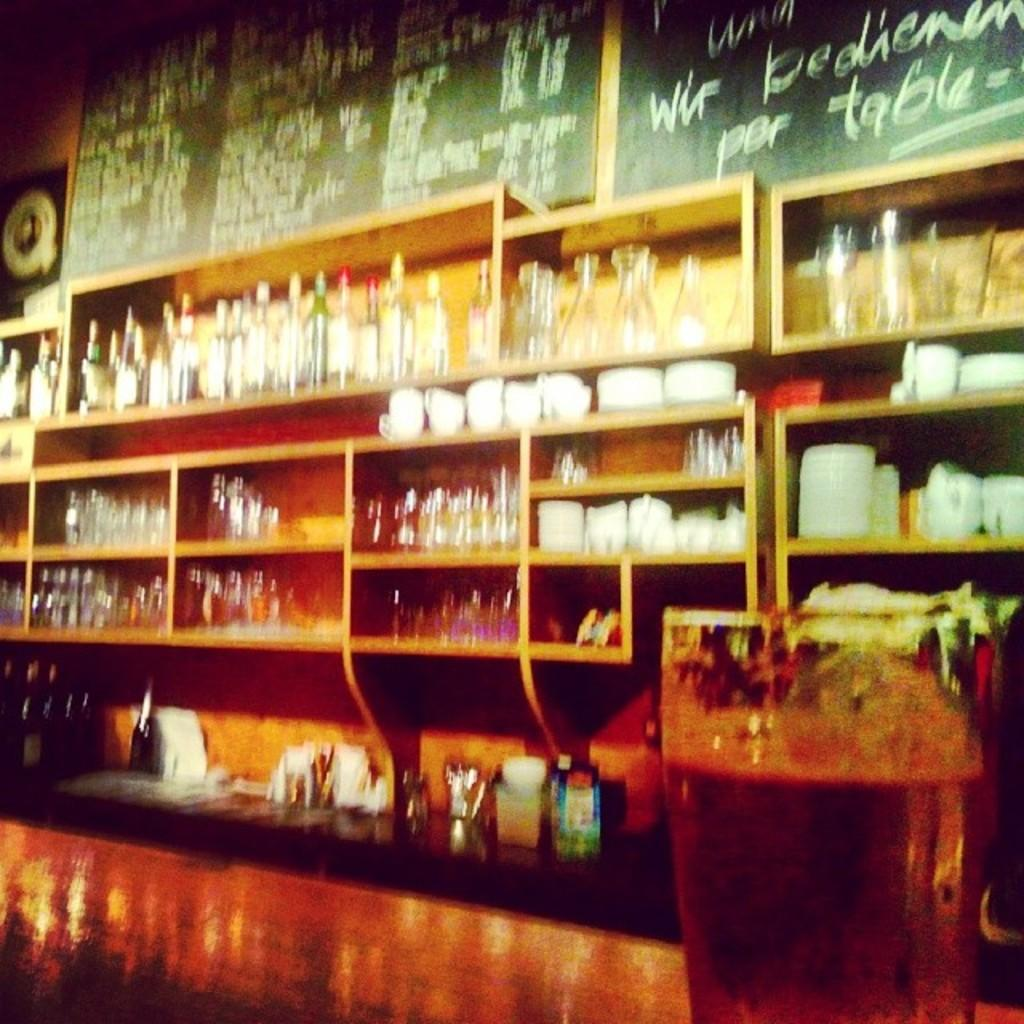<image>
Create a compact narrative representing the image presented. Above the shelves of glasses and dishes, the word table is written in chalk. 